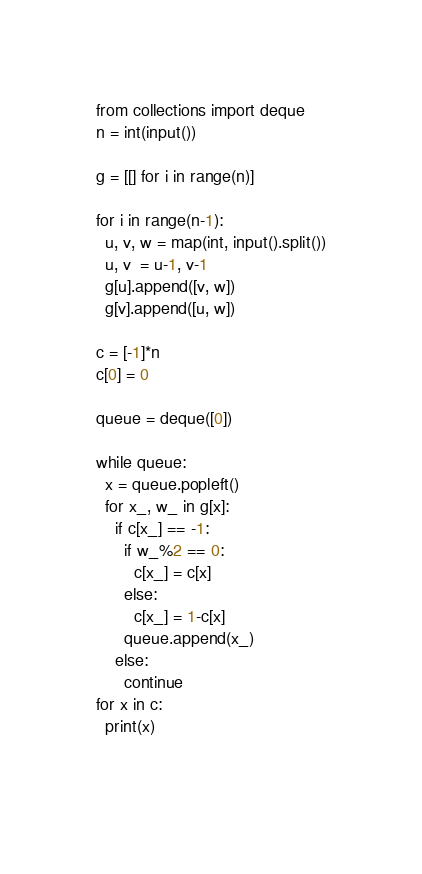<code> <loc_0><loc_0><loc_500><loc_500><_Python_>from collections import deque
n = int(input())

g = [[] for i in range(n)]

for i in range(n-1):
  u, v, w = map(int, input().split())
  u, v  = u-1, v-1
  g[u].append([v, w])
  g[v].append([u, w])

c = [-1]*n
c[0] = 0

queue = deque([0])

while queue:
  x = queue.popleft()
  for x_, w_ in g[x]:
    if c[x_] == -1:
      if w_%2 == 0:
        c[x_] = c[x]
      else:
        c[x_] = 1-c[x]
      queue.append(x_)
    else:
      continue
for x in c:
  print(x)
    
  

</code> 